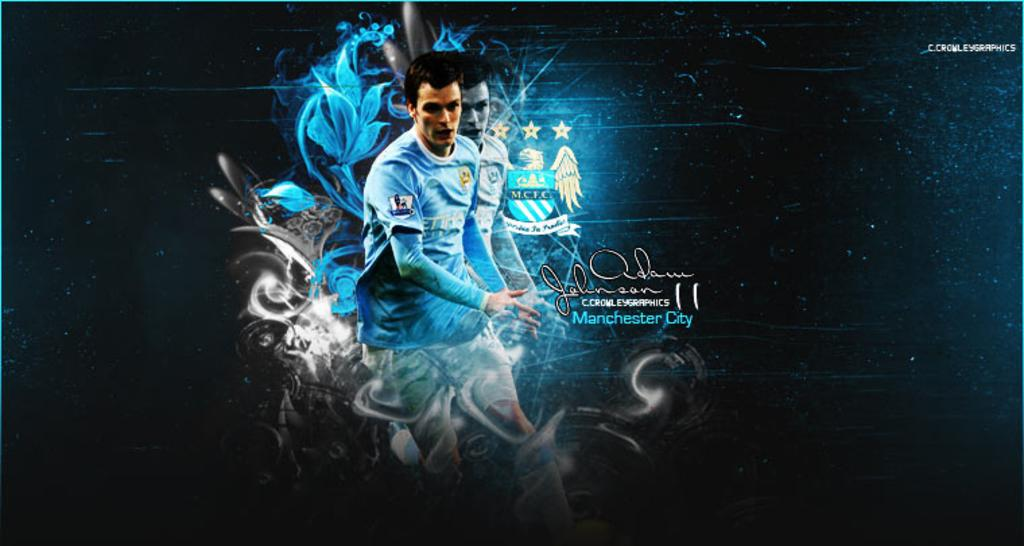<image>
Provide a brief description of the given image. A digital artwork featuring a player from Manchester City in a blue jersey. 